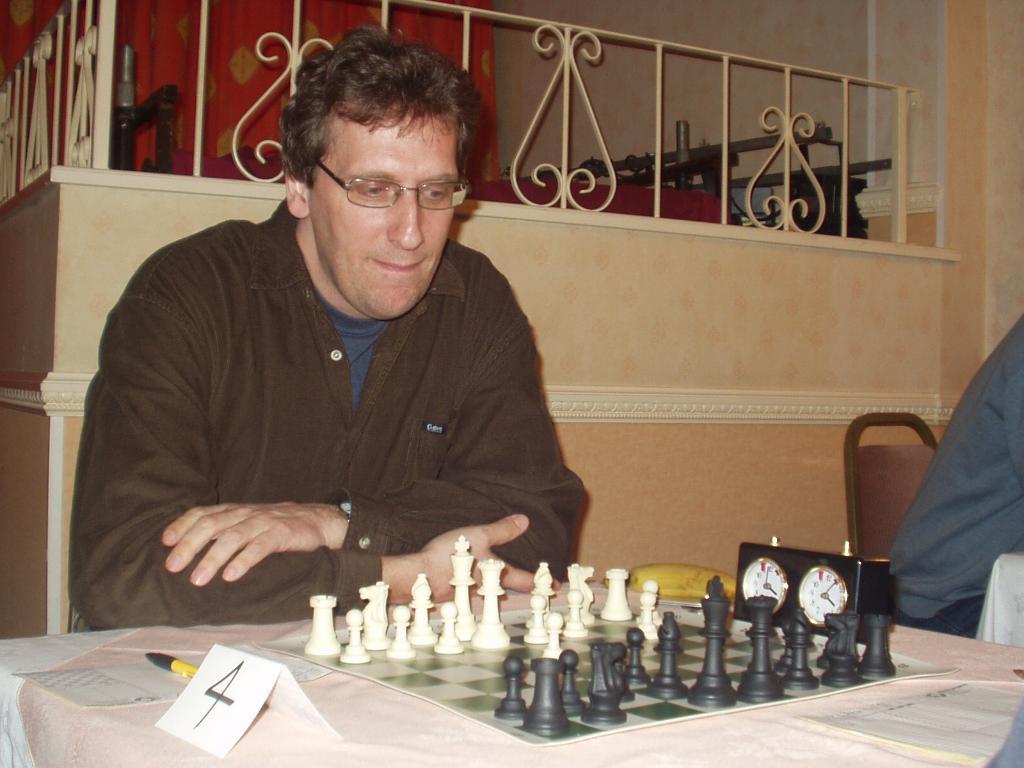In one or two sentences, can you explain what this image depicts? A man is playing chess. There is a paper on which number 4 is written and there is a timer. There is a fence at the back. 